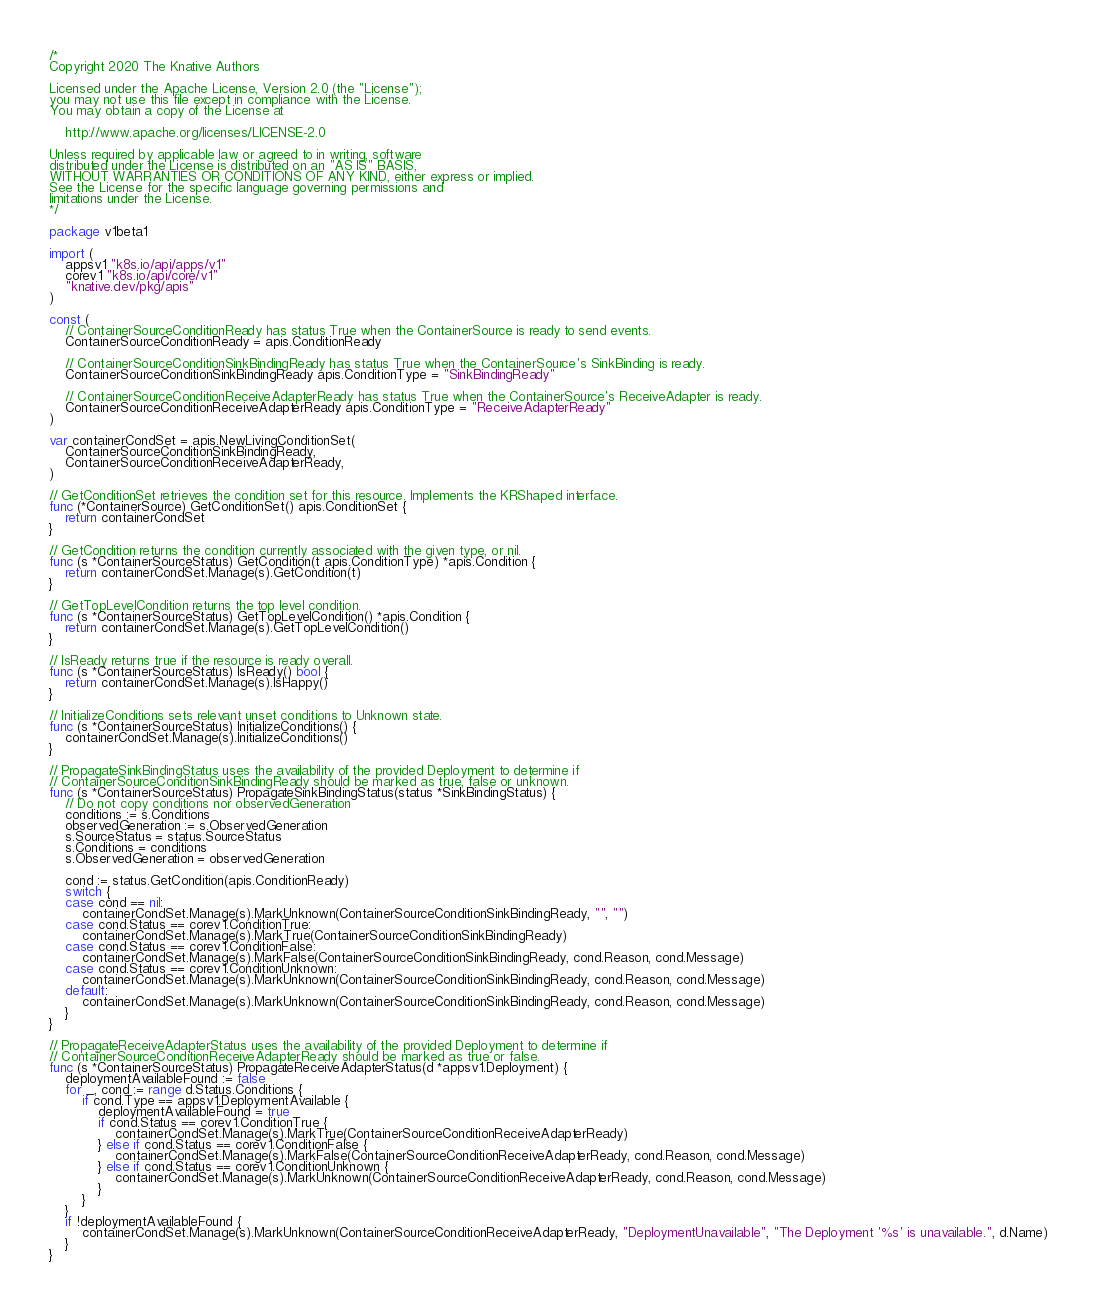Convert code to text. <code><loc_0><loc_0><loc_500><loc_500><_Go_>/*
Copyright 2020 The Knative Authors

Licensed under the Apache License, Version 2.0 (the "License");
you may not use this file except in compliance with the License.
You may obtain a copy of the License at

    http://www.apache.org/licenses/LICENSE-2.0

Unless required by applicable law or agreed to in writing, software
distributed under the License is distributed on an "AS IS" BASIS,
WITHOUT WARRANTIES OR CONDITIONS OF ANY KIND, either express or implied.
See the License for the specific language governing permissions and
limitations under the License.
*/

package v1beta1

import (
	appsv1 "k8s.io/api/apps/v1"
	corev1 "k8s.io/api/core/v1"
	"knative.dev/pkg/apis"
)

const (
	// ContainerSourceConditionReady has status True when the ContainerSource is ready to send events.
	ContainerSourceConditionReady = apis.ConditionReady

	// ContainerSourceConditionSinkBindingReady has status True when the ContainerSource's SinkBinding is ready.
	ContainerSourceConditionSinkBindingReady apis.ConditionType = "SinkBindingReady"

	// ContainerSourceConditionReceiveAdapterReady has status True when the ContainerSource's ReceiveAdapter is ready.
	ContainerSourceConditionReceiveAdapterReady apis.ConditionType = "ReceiveAdapterReady"
)

var containerCondSet = apis.NewLivingConditionSet(
	ContainerSourceConditionSinkBindingReady,
	ContainerSourceConditionReceiveAdapterReady,
)

// GetConditionSet retrieves the condition set for this resource. Implements the KRShaped interface.
func (*ContainerSource) GetConditionSet() apis.ConditionSet {
	return containerCondSet
}

// GetCondition returns the condition currently associated with the given type, or nil.
func (s *ContainerSourceStatus) GetCondition(t apis.ConditionType) *apis.Condition {
	return containerCondSet.Manage(s).GetCondition(t)
}

// GetTopLevelCondition returns the top level condition.
func (s *ContainerSourceStatus) GetTopLevelCondition() *apis.Condition {
	return containerCondSet.Manage(s).GetTopLevelCondition()
}

// IsReady returns true if the resource is ready overall.
func (s *ContainerSourceStatus) IsReady() bool {
	return containerCondSet.Manage(s).IsHappy()
}

// InitializeConditions sets relevant unset conditions to Unknown state.
func (s *ContainerSourceStatus) InitializeConditions() {
	containerCondSet.Manage(s).InitializeConditions()
}

// PropagateSinkBindingStatus uses the availability of the provided Deployment to determine if
// ContainerSourceConditionSinkBindingReady should be marked as true, false or unknown.
func (s *ContainerSourceStatus) PropagateSinkBindingStatus(status *SinkBindingStatus) {
	// Do not copy conditions nor observedGeneration
	conditions := s.Conditions
	observedGeneration := s.ObservedGeneration
	s.SourceStatus = status.SourceStatus
	s.Conditions = conditions
	s.ObservedGeneration = observedGeneration

	cond := status.GetCondition(apis.ConditionReady)
	switch {
	case cond == nil:
		containerCondSet.Manage(s).MarkUnknown(ContainerSourceConditionSinkBindingReady, "", "")
	case cond.Status == corev1.ConditionTrue:
		containerCondSet.Manage(s).MarkTrue(ContainerSourceConditionSinkBindingReady)
	case cond.Status == corev1.ConditionFalse:
		containerCondSet.Manage(s).MarkFalse(ContainerSourceConditionSinkBindingReady, cond.Reason, cond.Message)
	case cond.Status == corev1.ConditionUnknown:
		containerCondSet.Manage(s).MarkUnknown(ContainerSourceConditionSinkBindingReady, cond.Reason, cond.Message)
	default:
		containerCondSet.Manage(s).MarkUnknown(ContainerSourceConditionSinkBindingReady, cond.Reason, cond.Message)
	}
}

// PropagateReceiveAdapterStatus uses the availability of the provided Deployment to determine if
// ContainerSourceConditionReceiveAdapterReady should be marked as true or false.
func (s *ContainerSourceStatus) PropagateReceiveAdapterStatus(d *appsv1.Deployment) {
	deploymentAvailableFound := false
	for _, cond := range d.Status.Conditions {
		if cond.Type == appsv1.DeploymentAvailable {
			deploymentAvailableFound = true
			if cond.Status == corev1.ConditionTrue {
				containerCondSet.Manage(s).MarkTrue(ContainerSourceConditionReceiveAdapterReady)
			} else if cond.Status == corev1.ConditionFalse {
				containerCondSet.Manage(s).MarkFalse(ContainerSourceConditionReceiveAdapterReady, cond.Reason, cond.Message)
			} else if cond.Status == corev1.ConditionUnknown {
				containerCondSet.Manage(s).MarkUnknown(ContainerSourceConditionReceiveAdapterReady, cond.Reason, cond.Message)
			}
		}
	}
	if !deploymentAvailableFound {
		containerCondSet.Manage(s).MarkUnknown(ContainerSourceConditionReceiveAdapterReady, "DeploymentUnavailable", "The Deployment '%s' is unavailable.", d.Name)
	}
}
</code> 